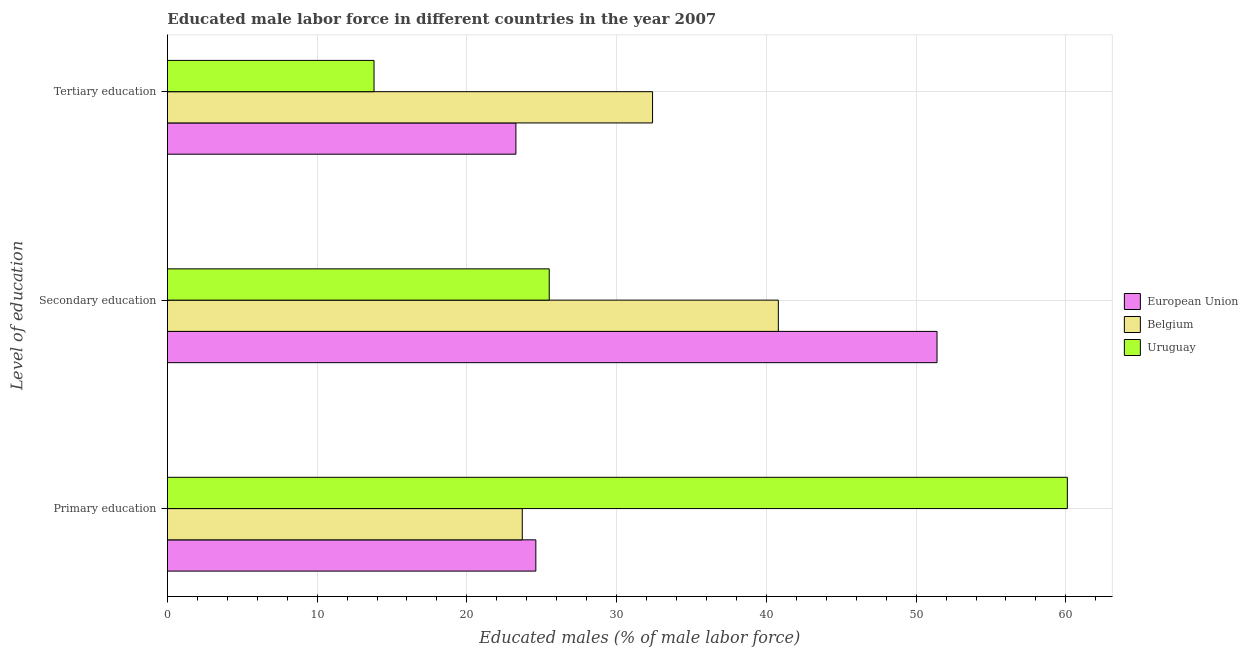How many groups of bars are there?
Provide a succinct answer. 3. Are the number of bars per tick equal to the number of legend labels?
Make the answer very short. Yes. Are the number of bars on each tick of the Y-axis equal?
Keep it short and to the point. Yes. What is the label of the 3rd group of bars from the top?
Provide a short and direct response. Primary education. What is the percentage of male labor force who received secondary education in Uruguay?
Your answer should be very brief. 25.5. Across all countries, what is the maximum percentage of male labor force who received tertiary education?
Offer a terse response. 32.4. Across all countries, what is the minimum percentage of male labor force who received tertiary education?
Ensure brevity in your answer.  13.8. In which country was the percentage of male labor force who received tertiary education maximum?
Give a very brief answer. Belgium. In which country was the percentage of male labor force who received secondary education minimum?
Your answer should be very brief. Uruguay. What is the total percentage of male labor force who received primary education in the graph?
Offer a terse response. 108.41. What is the difference between the percentage of male labor force who received tertiary education in European Union and that in Belgium?
Provide a short and direct response. -9.13. What is the difference between the percentage of male labor force who received secondary education in Belgium and the percentage of male labor force who received primary education in European Union?
Give a very brief answer. 16.19. What is the average percentage of male labor force who received secondary education per country?
Provide a short and direct response. 39.23. What is the difference between the percentage of male labor force who received primary education and percentage of male labor force who received tertiary education in European Union?
Your answer should be very brief. 1.33. What is the ratio of the percentage of male labor force who received secondary education in European Union to that in Belgium?
Provide a succinct answer. 1.26. Is the percentage of male labor force who received primary education in Uruguay less than that in Belgium?
Provide a succinct answer. No. Is the difference between the percentage of male labor force who received tertiary education in Belgium and Uruguay greater than the difference between the percentage of male labor force who received secondary education in Belgium and Uruguay?
Offer a terse response. Yes. What is the difference between the highest and the second highest percentage of male labor force who received secondary education?
Your response must be concise. 10.6. What is the difference between the highest and the lowest percentage of male labor force who received tertiary education?
Provide a succinct answer. 18.6. In how many countries, is the percentage of male labor force who received tertiary education greater than the average percentage of male labor force who received tertiary education taken over all countries?
Your answer should be compact. 2. What does the 1st bar from the top in Primary education represents?
Provide a succinct answer. Uruguay. What does the 2nd bar from the bottom in Secondary education represents?
Offer a very short reply. Belgium. Is it the case that in every country, the sum of the percentage of male labor force who received primary education and percentage of male labor force who received secondary education is greater than the percentage of male labor force who received tertiary education?
Your answer should be very brief. Yes. How many bars are there?
Your response must be concise. 9. How many countries are there in the graph?
Ensure brevity in your answer.  3. Does the graph contain any zero values?
Your response must be concise. No. Does the graph contain grids?
Your response must be concise. Yes. Where does the legend appear in the graph?
Your response must be concise. Center right. What is the title of the graph?
Your response must be concise. Educated male labor force in different countries in the year 2007. What is the label or title of the X-axis?
Offer a terse response. Educated males (% of male labor force). What is the label or title of the Y-axis?
Ensure brevity in your answer.  Level of education. What is the Educated males (% of male labor force) in European Union in Primary education?
Provide a succinct answer. 24.61. What is the Educated males (% of male labor force) of Belgium in Primary education?
Provide a succinct answer. 23.7. What is the Educated males (% of male labor force) in Uruguay in Primary education?
Make the answer very short. 60.1. What is the Educated males (% of male labor force) of European Union in Secondary education?
Provide a short and direct response. 51.4. What is the Educated males (% of male labor force) of Belgium in Secondary education?
Your answer should be very brief. 40.8. What is the Educated males (% of male labor force) of Uruguay in Secondary education?
Your answer should be compact. 25.5. What is the Educated males (% of male labor force) of European Union in Tertiary education?
Make the answer very short. 23.27. What is the Educated males (% of male labor force) of Belgium in Tertiary education?
Ensure brevity in your answer.  32.4. What is the Educated males (% of male labor force) in Uruguay in Tertiary education?
Keep it short and to the point. 13.8. Across all Level of education, what is the maximum Educated males (% of male labor force) in European Union?
Your answer should be very brief. 51.4. Across all Level of education, what is the maximum Educated males (% of male labor force) in Belgium?
Your answer should be compact. 40.8. Across all Level of education, what is the maximum Educated males (% of male labor force) in Uruguay?
Offer a very short reply. 60.1. Across all Level of education, what is the minimum Educated males (% of male labor force) of European Union?
Keep it short and to the point. 23.27. Across all Level of education, what is the minimum Educated males (% of male labor force) in Belgium?
Provide a short and direct response. 23.7. Across all Level of education, what is the minimum Educated males (% of male labor force) of Uruguay?
Offer a terse response. 13.8. What is the total Educated males (% of male labor force) in European Union in the graph?
Provide a succinct answer. 99.28. What is the total Educated males (% of male labor force) in Belgium in the graph?
Your response must be concise. 96.9. What is the total Educated males (% of male labor force) in Uruguay in the graph?
Provide a succinct answer. 99.4. What is the difference between the Educated males (% of male labor force) of European Union in Primary education and that in Secondary education?
Your answer should be very brief. -26.79. What is the difference between the Educated males (% of male labor force) of Belgium in Primary education and that in Secondary education?
Your response must be concise. -17.1. What is the difference between the Educated males (% of male labor force) in Uruguay in Primary education and that in Secondary education?
Your answer should be compact. 34.6. What is the difference between the Educated males (% of male labor force) in European Union in Primary education and that in Tertiary education?
Your response must be concise. 1.33. What is the difference between the Educated males (% of male labor force) of Uruguay in Primary education and that in Tertiary education?
Provide a short and direct response. 46.3. What is the difference between the Educated males (% of male labor force) of European Union in Secondary education and that in Tertiary education?
Ensure brevity in your answer.  28.12. What is the difference between the Educated males (% of male labor force) of Belgium in Secondary education and that in Tertiary education?
Your answer should be very brief. 8.4. What is the difference between the Educated males (% of male labor force) of European Union in Primary education and the Educated males (% of male labor force) of Belgium in Secondary education?
Provide a succinct answer. -16.19. What is the difference between the Educated males (% of male labor force) of European Union in Primary education and the Educated males (% of male labor force) of Uruguay in Secondary education?
Offer a very short reply. -0.89. What is the difference between the Educated males (% of male labor force) in European Union in Primary education and the Educated males (% of male labor force) in Belgium in Tertiary education?
Provide a succinct answer. -7.79. What is the difference between the Educated males (% of male labor force) of European Union in Primary education and the Educated males (% of male labor force) of Uruguay in Tertiary education?
Your answer should be compact. 10.81. What is the difference between the Educated males (% of male labor force) in European Union in Secondary education and the Educated males (% of male labor force) in Belgium in Tertiary education?
Offer a terse response. 19. What is the difference between the Educated males (% of male labor force) in European Union in Secondary education and the Educated males (% of male labor force) in Uruguay in Tertiary education?
Your response must be concise. 37.6. What is the difference between the Educated males (% of male labor force) of Belgium in Secondary education and the Educated males (% of male labor force) of Uruguay in Tertiary education?
Your response must be concise. 27. What is the average Educated males (% of male labor force) of European Union per Level of education?
Provide a succinct answer. 33.09. What is the average Educated males (% of male labor force) in Belgium per Level of education?
Ensure brevity in your answer.  32.3. What is the average Educated males (% of male labor force) of Uruguay per Level of education?
Offer a terse response. 33.13. What is the difference between the Educated males (% of male labor force) in European Union and Educated males (% of male labor force) in Belgium in Primary education?
Keep it short and to the point. 0.91. What is the difference between the Educated males (% of male labor force) in European Union and Educated males (% of male labor force) in Uruguay in Primary education?
Your response must be concise. -35.49. What is the difference between the Educated males (% of male labor force) in Belgium and Educated males (% of male labor force) in Uruguay in Primary education?
Provide a succinct answer. -36.4. What is the difference between the Educated males (% of male labor force) of European Union and Educated males (% of male labor force) of Belgium in Secondary education?
Offer a terse response. 10.6. What is the difference between the Educated males (% of male labor force) of European Union and Educated males (% of male labor force) of Uruguay in Secondary education?
Offer a terse response. 25.9. What is the difference between the Educated males (% of male labor force) in European Union and Educated males (% of male labor force) in Belgium in Tertiary education?
Keep it short and to the point. -9.13. What is the difference between the Educated males (% of male labor force) in European Union and Educated males (% of male labor force) in Uruguay in Tertiary education?
Your answer should be very brief. 9.47. What is the ratio of the Educated males (% of male labor force) of European Union in Primary education to that in Secondary education?
Provide a short and direct response. 0.48. What is the ratio of the Educated males (% of male labor force) of Belgium in Primary education to that in Secondary education?
Offer a terse response. 0.58. What is the ratio of the Educated males (% of male labor force) in Uruguay in Primary education to that in Secondary education?
Keep it short and to the point. 2.36. What is the ratio of the Educated males (% of male labor force) in European Union in Primary education to that in Tertiary education?
Ensure brevity in your answer.  1.06. What is the ratio of the Educated males (% of male labor force) of Belgium in Primary education to that in Tertiary education?
Your answer should be compact. 0.73. What is the ratio of the Educated males (% of male labor force) in Uruguay in Primary education to that in Tertiary education?
Offer a very short reply. 4.36. What is the ratio of the Educated males (% of male labor force) in European Union in Secondary education to that in Tertiary education?
Your answer should be compact. 2.21. What is the ratio of the Educated males (% of male labor force) in Belgium in Secondary education to that in Tertiary education?
Your answer should be very brief. 1.26. What is the ratio of the Educated males (% of male labor force) of Uruguay in Secondary education to that in Tertiary education?
Your answer should be very brief. 1.85. What is the difference between the highest and the second highest Educated males (% of male labor force) of European Union?
Your answer should be compact. 26.79. What is the difference between the highest and the second highest Educated males (% of male labor force) in Belgium?
Provide a short and direct response. 8.4. What is the difference between the highest and the second highest Educated males (% of male labor force) of Uruguay?
Your response must be concise. 34.6. What is the difference between the highest and the lowest Educated males (% of male labor force) in European Union?
Provide a short and direct response. 28.12. What is the difference between the highest and the lowest Educated males (% of male labor force) of Uruguay?
Your response must be concise. 46.3. 